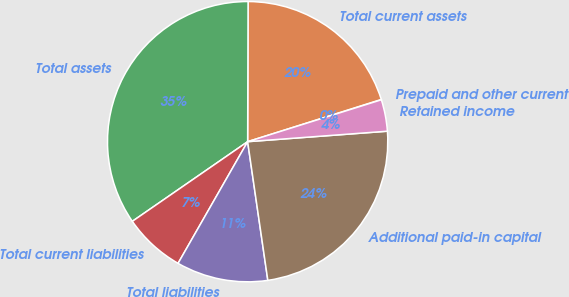Convert chart. <chart><loc_0><loc_0><loc_500><loc_500><pie_chart><fcel>Prepaid and other current<fcel>Total current assets<fcel>Total assets<fcel>Total current liabilities<fcel>Total liabilities<fcel>Additional paid-in capital<fcel>Retained income<nl><fcel>0.04%<fcel>20.08%<fcel>34.67%<fcel>7.11%<fcel>10.57%<fcel>23.89%<fcel>3.64%<nl></chart> 